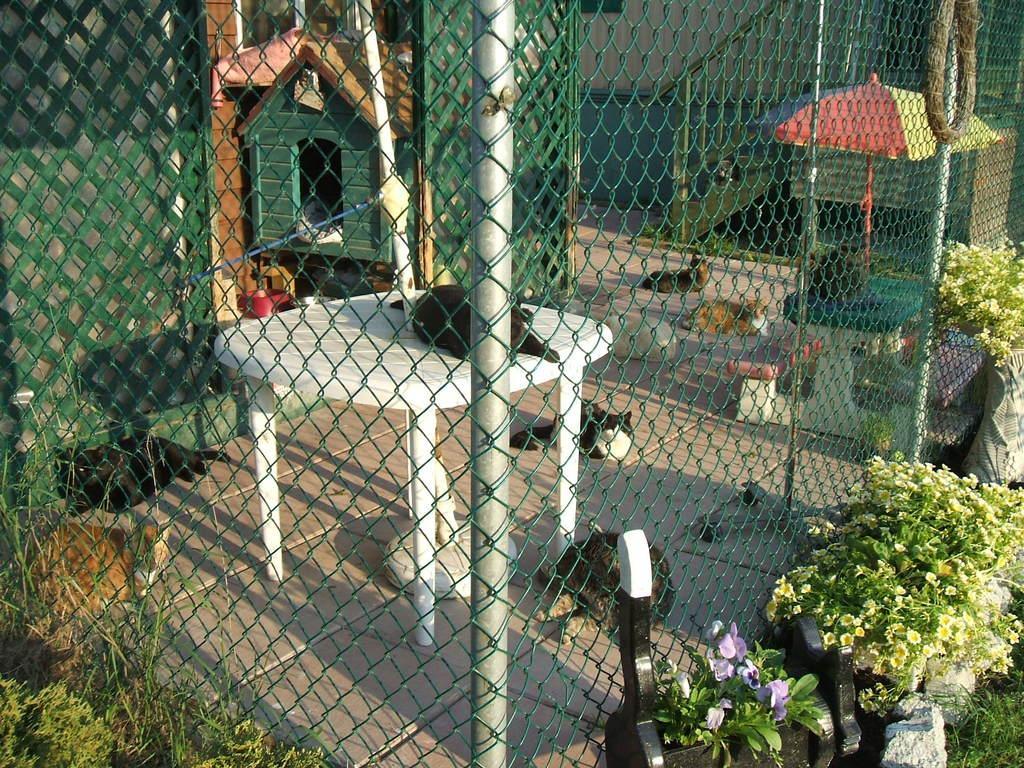Describe this image in one or two sentences. In this image we can see many animals. There is a fencing in the image. There are many plants in the image. There are few tables in the image. There is an animal on the table. There are flowers to the plants. There is a cattery in the image. 